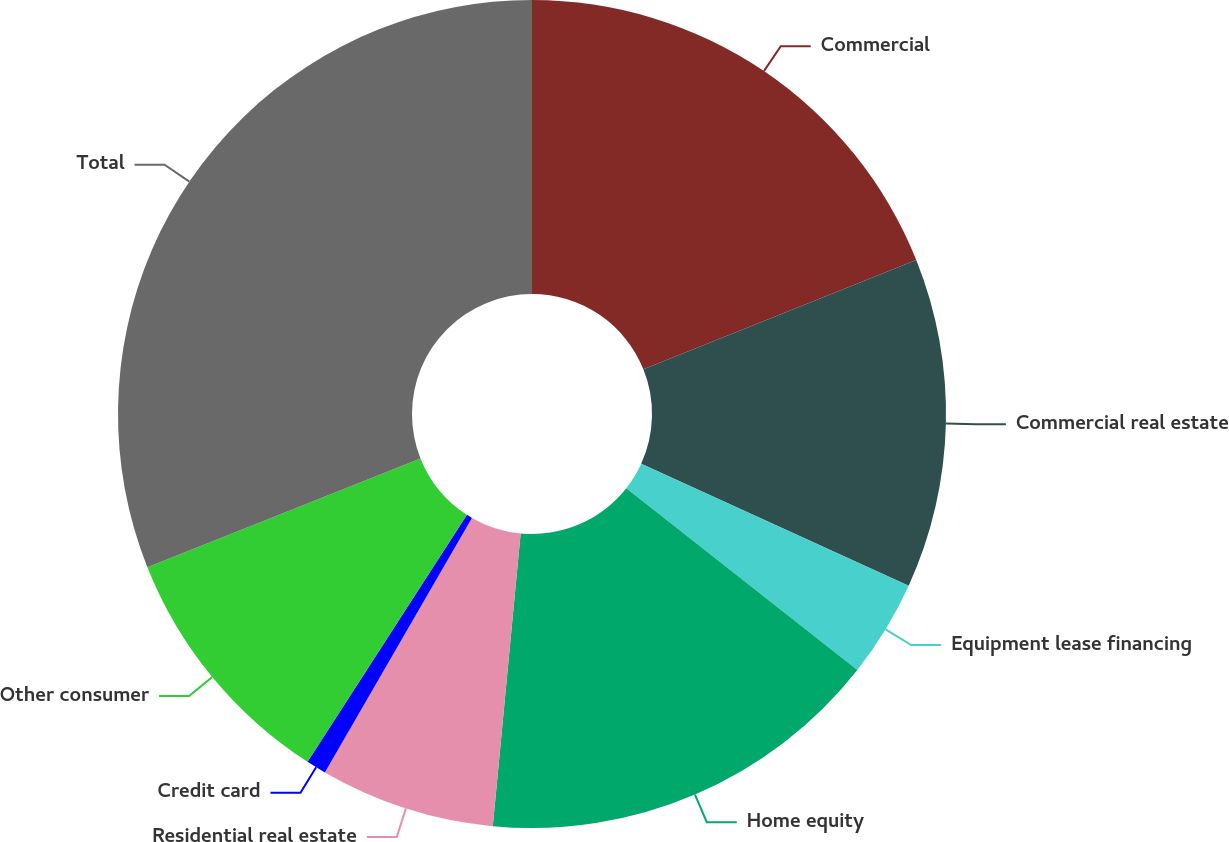Convert chart to OTSL. <chart><loc_0><loc_0><loc_500><loc_500><pie_chart><fcel>Commercial<fcel>Commercial real estate<fcel>Equipment lease financing<fcel>Home equity<fcel>Residential real estate<fcel>Credit card<fcel>Other consumer<fcel>Total<nl><fcel>18.93%<fcel>12.88%<fcel>3.8%<fcel>15.9%<fcel>6.83%<fcel>0.78%<fcel>9.85%<fcel>31.03%<nl></chart> 